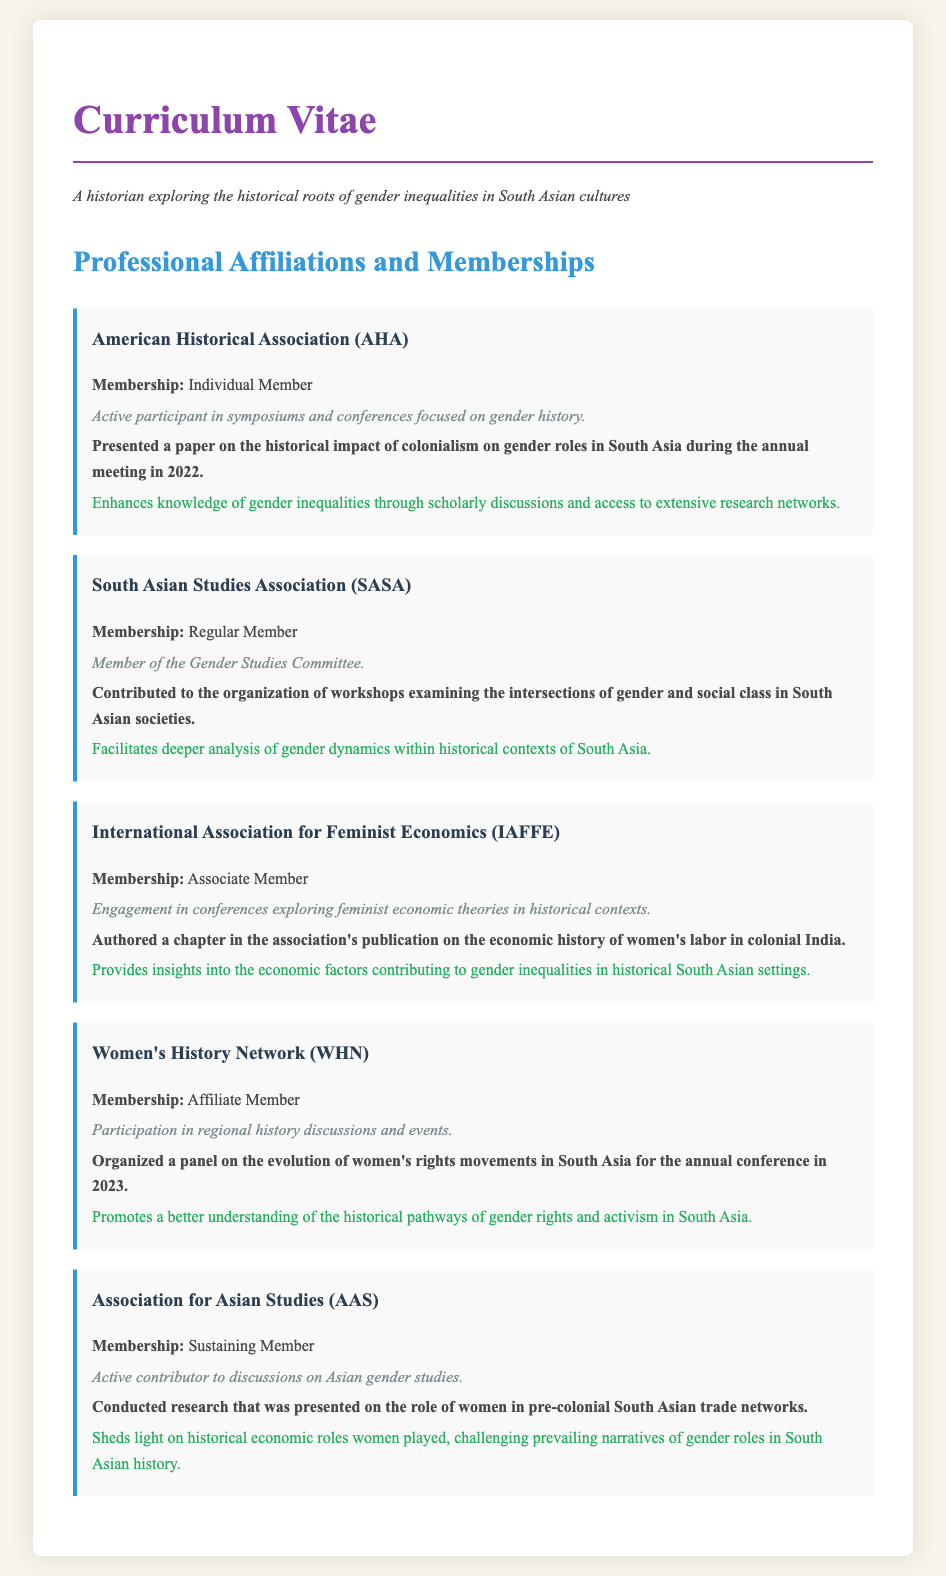What is the membership type for the American Historical Association? The document specifies the membership type listed for the American Historical Association.
Answer: Individual Member What paper was presented at the American Historical Association annual meeting? The document mentions the paper presented in 2022 related to gender roles in South Asia.
Answer: The historical impact of colonialism on gender roles in South Asia Which committee is the South Asian Studies Association member a part of? The document indicates the committee associated with the South Asian Studies Association membership.
Answer: Gender Studies Committee What contribution did the International Association for Feminist Economics member make? The document highlights the specific contribution made by the member in relation to women's labor history.
Answer: Authored a chapter in the association's publication on the economic history of women's labor in colonial India What event did the Women's History Network organize in 2023? The document provides details about an event focused on women's rights movements organized by the member.
Answer: A panel on the evolution of women's rights movements in South Asia How does the Association for Asian Studies membership enhance understanding? The document explains how this membership contributes to historical narratives concerning gender roles.
Answer: Sheds light on historical economic roles women played, challenging prevailing narratives of gender roles in South Asian history 